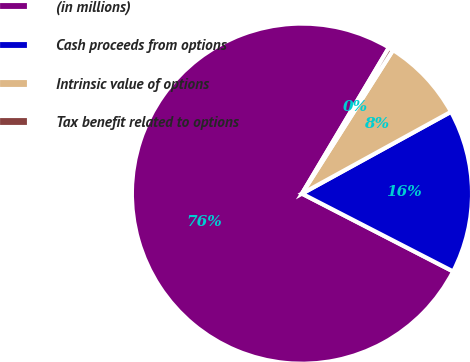<chart> <loc_0><loc_0><loc_500><loc_500><pie_chart><fcel>(in millions)<fcel>Cash proceeds from options<fcel>Intrinsic value of options<fcel>Tax benefit related to options<nl><fcel>75.98%<fcel>15.56%<fcel>8.01%<fcel>0.45%<nl></chart> 